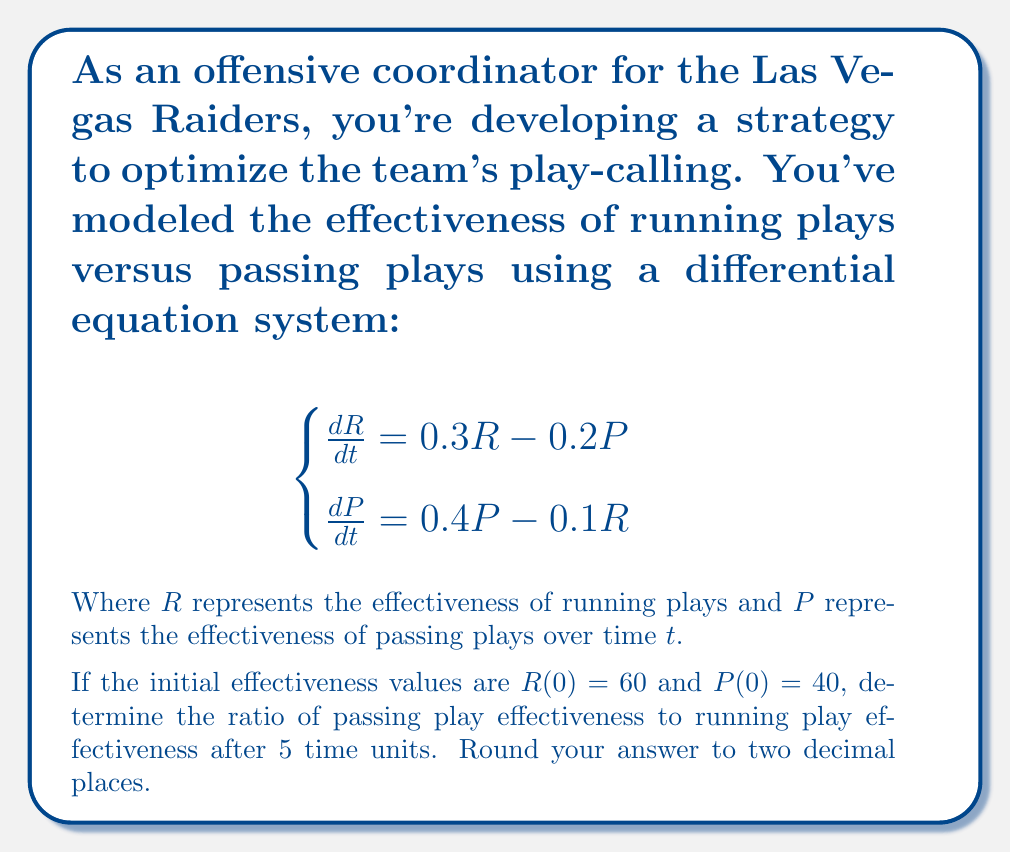Provide a solution to this math problem. Let's approach this step-by-step:

1) We need to solve the system of differential equations. This is a linear system, and we can solve it using eigenvalues and eigenvectors.

2) The characteristic equation is:
   $$\begin{vmatrix} 
   0.3 - \lambda & -0.2 \\
   -0.1 & 0.4 - \lambda
   \end{vmatrix} = 0$$

3) Solving this, we get:
   $(0.3 - \lambda)(0.4 - \lambda) - 0.02 = 0$
   $\lambda^2 - 0.7\lambda + 0.1 = 0$

4) The eigenvalues are:
   $\lambda_1 = 0.5$ and $\lambda_2 = 0.2$

5) The general solution is of the form:
   $$\begin{pmatrix} R \\ P \end{pmatrix} = c_1e^{0.5t}\vec{v_1} + c_2e^{0.2t}\vec{v_2}$$
   where $\vec{v_1}$ and $\vec{v_2}$ are the eigenvectors.

6) After calculating the eigenvectors and applying initial conditions, we get:
   $$\begin{pmatrix} R \\ P \end{pmatrix} = 40e^{0.5t}\begin{pmatrix} 1 \\ 2 \end{pmatrix} + 20e^{0.2t}\begin{pmatrix} 1 \\ -1 \end{pmatrix}$$

7) At $t = 5$:
   $$R(5) = 40e^{0.5(5)} + 20e^{0.2(5)} = 40(11.18) + 20(2.72) = 501.2$$
   $$P(5) = 80e^{0.5(5)} - 20e^{0.2(5)} = 80(11.18) - 20(2.72) = 840.4$$

8) The ratio of passing play effectiveness to running play effectiveness is:
   $$\frac{P(5)}{R(5)} = \frac{840.4}{501.2} \approx 1.68$$
Answer: 1.68 